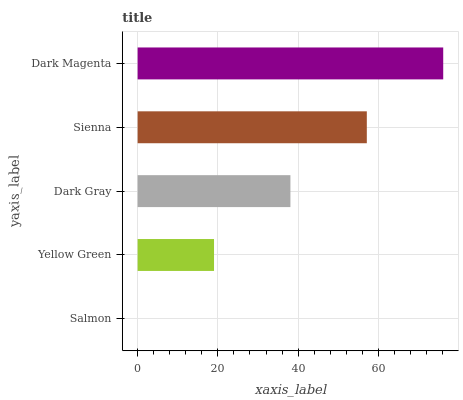Is Salmon the minimum?
Answer yes or no. Yes. Is Dark Magenta the maximum?
Answer yes or no. Yes. Is Yellow Green the minimum?
Answer yes or no. No. Is Yellow Green the maximum?
Answer yes or no. No. Is Yellow Green greater than Salmon?
Answer yes or no. Yes. Is Salmon less than Yellow Green?
Answer yes or no. Yes. Is Salmon greater than Yellow Green?
Answer yes or no. No. Is Yellow Green less than Salmon?
Answer yes or no. No. Is Dark Gray the high median?
Answer yes or no. Yes. Is Dark Gray the low median?
Answer yes or no. Yes. Is Dark Magenta the high median?
Answer yes or no. No. Is Dark Magenta the low median?
Answer yes or no. No. 